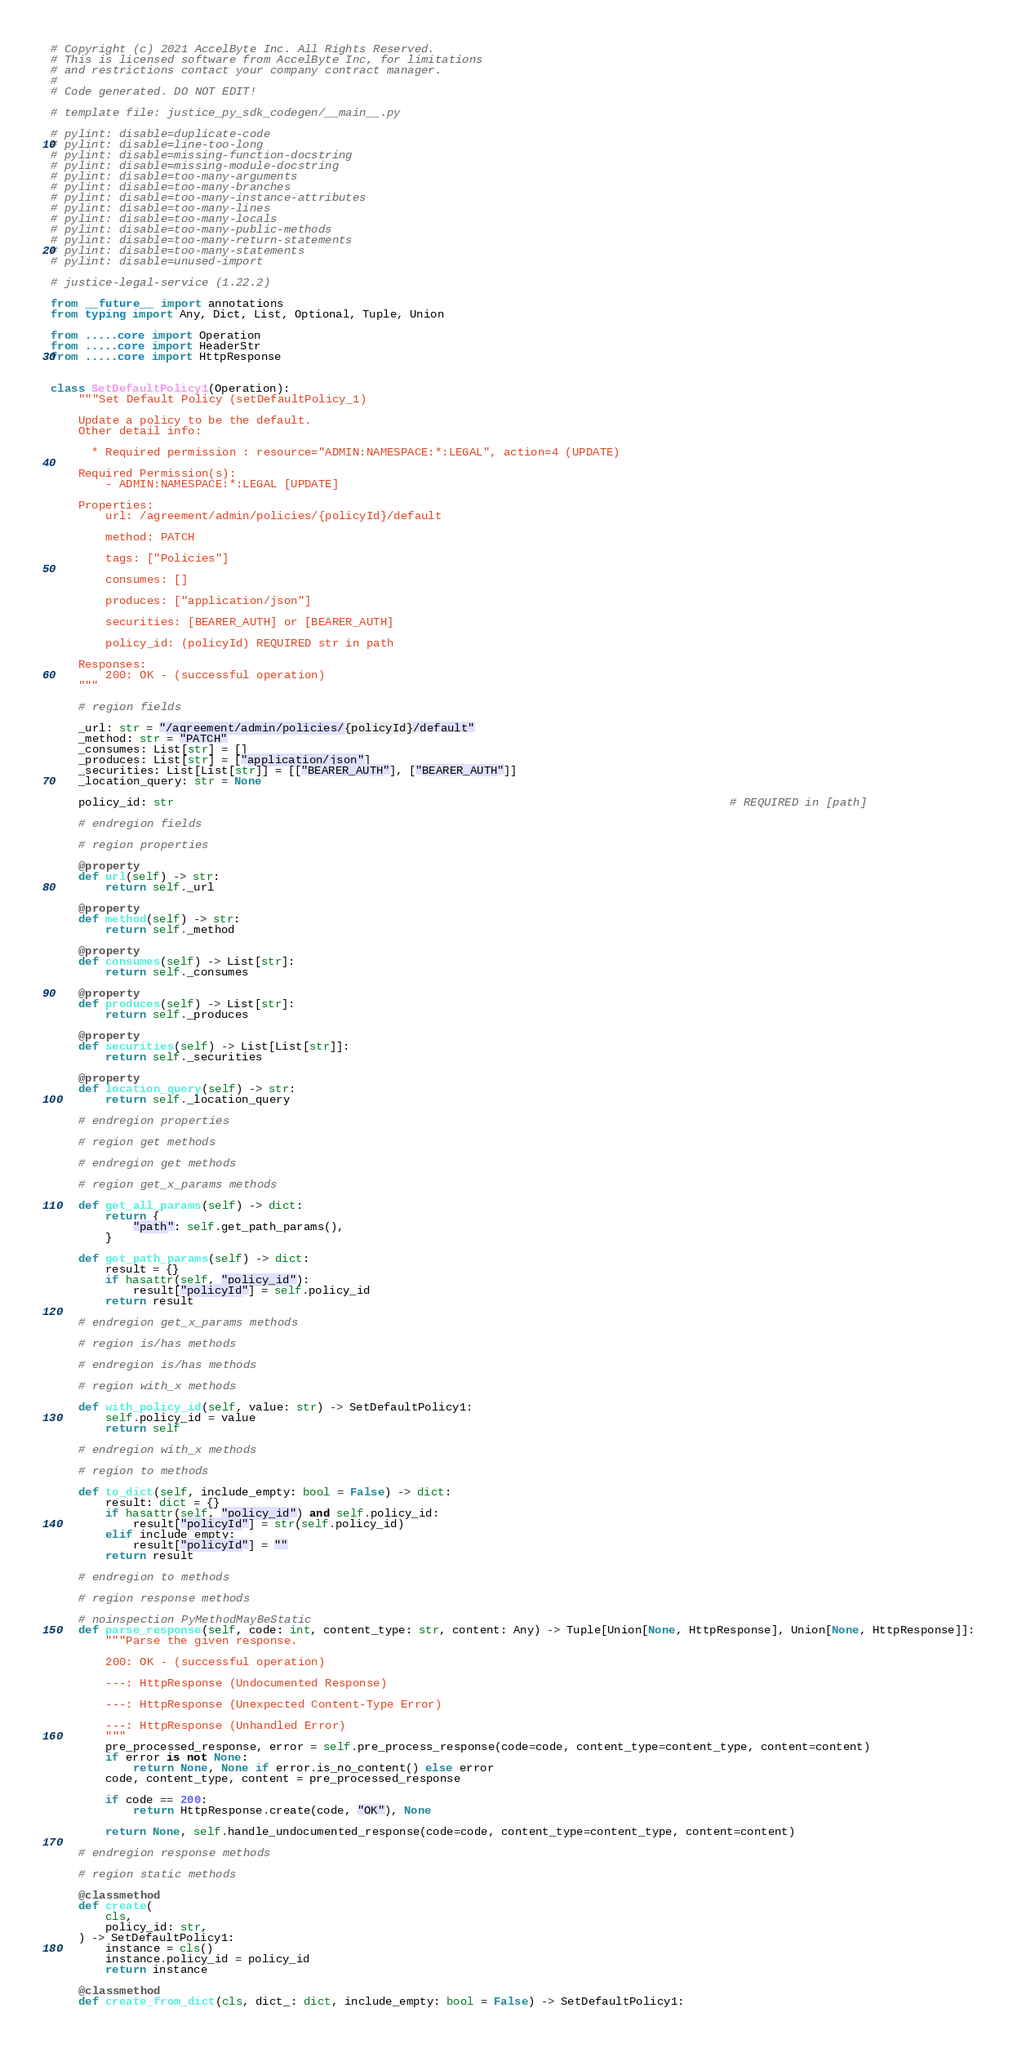Convert code to text. <code><loc_0><loc_0><loc_500><loc_500><_Python_># Copyright (c) 2021 AccelByte Inc. All Rights Reserved.
# This is licensed software from AccelByte Inc, for limitations
# and restrictions contact your company contract manager.
# 
# Code generated. DO NOT EDIT!

# template file: justice_py_sdk_codegen/__main__.py

# pylint: disable=duplicate-code
# pylint: disable=line-too-long
# pylint: disable=missing-function-docstring
# pylint: disable=missing-module-docstring
# pylint: disable=too-many-arguments
# pylint: disable=too-many-branches
# pylint: disable=too-many-instance-attributes
# pylint: disable=too-many-lines
# pylint: disable=too-many-locals
# pylint: disable=too-many-public-methods
# pylint: disable=too-many-return-statements
# pylint: disable=too-many-statements
# pylint: disable=unused-import

# justice-legal-service (1.22.2)

from __future__ import annotations
from typing import Any, Dict, List, Optional, Tuple, Union

from .....core import Operation
from .....core import HeaderStr
from .....core import HttpResponse


class SetDefaultPolicy1(Operation):
    """Set Default Policy (setDefaultPolicy_1)

    Update a policy to be the default.
    Other detail info:

      * Required permission : resource="ADMIN:NAMESPACE:*:LEGAL", action=4 (UPDATE)

    Required Permission(s):
        - ADMIN:NAMESPACE:*:LEGAL [UPDATE]

    Properties:
        url: /agreement/admin/policies/{policyId}/default

        method: PATCH

        tags: ["Policies"]

        consumes: []

        produces: ["application/json"]

        securities: [BEARER_AUTH] or [BEARER_AUTH]

        policy_id: (policyId) REQUIRED str in path

    Responses:
        200: OK - (successful operation)
    """

    # region fields

    _url: str = "/agreement/admin/policies/{policyId}/default"
    _method: str = "PATCH"
    _consumes: List[str] = []
    _produces: List[str] = ["application/json"]
    _securities: List[List[str]] = [["BEARER_AUTH"], ["BEARER_AUTH"]]
    _location_query: str = None

    policy_id: str                                                                                 # REQUIRED in [path]

    # endregion fields

    # region properties

    @property
    def url(self) -> str:
        return self._url

    @property
    def method(self) -> str:
        return self._method

    @property
    def consumes(self) -> List[str]:
        return self._consumes

    @property
    def produces(self) -> List[str]:
        return self._produces

    @property
    def securities(self) -> List[List[str]]:
        return self._securities

    @property
    def location_query(self) -> str:
        return self._location_query

    # endregion properties

    # region get methods

    # endregion get methods

    # region get_x_params methods

    def get_all_params(self) -> dict:
        return {
            "path": self.get_path_params(),
        }

    def get_path_params(self) -> dict:
        result = {}
        if hasattr(self, "policy_id"):
            result["policyId"] = self.policy_id
        return result

    # endregion get_x_params methods

    # region is/has methods

    # endregion is/has methods

    # region with_x methods

    def with_policy_id(self, value: str) -> SetDefaultPolicy1:
        self.policy_id = value
        return self

    # endregion with_x methods

    # region to methods

    def to_dict(self, include_empty: bool = False) -> dict:
        result: dict = {}
        if hasattr(self, "policy_id") and self.policy_id:
            result["policyId"] = str(self.policy_id)
        elif include_empty:
            result["policyId"] = ""
        return result

    # endregion to methods

    # region response methods

    # noinspection PyMethodMayBeStatic
    def parse_response(self, code: int, content_type: str, content: Any) -> Tuple[Union[None, HttpResponse], Union[None, HttpResponse]]:
        """Parse the given response.

        200: OK - (successful operation)

        ---: HttpResponse (Undocumented Response)

        ---: HttpResponse (Unexpected Content-Type Error)

        ---: HttpResponse (Unhandled Error)
        """
        pre_processed_response, error = self.pre_process_response(code=code, content_type=content_type, content=content)
        if error is not None:
            return None, None if error.is_no_content() else error
        code, content_type, content = pre_processed_response

        if code == 200:
            return HttpResponse.create(code, "OK"), None

        return None, self.handle_undocumented_response(code=code, content_type=content_type, content=content)

    # endregion response methods

    # region static methods

    @classmethod
    def create(
        cls,
        policy_id: str,
    ) -> SetDefaultPolicy1:
        instance = cls()
        instance.policy_id = policy_id
        return instance

    @classmethod
    def create_from_dict(cls, dict_: dict, include_empty: bool = False) -> SetDefaultPolicy1:</code> 